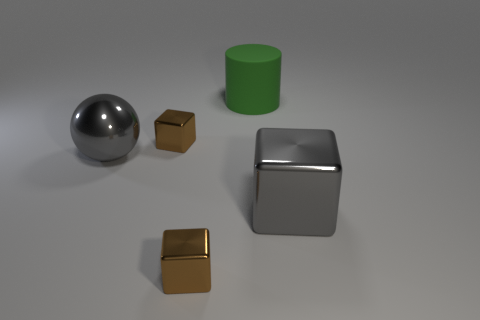Is there any other thing that is made of the same material as the big green cylinder?
Offer a terse response. No. Does the large green matte object have the same shape as the large gray object to the left of the green rubber object?
Give a very brief answer. No. What is the shape of the object that is the same color as the large sphere?
Provide a succinct answer. Cube. Are there fewer gray objects behind the gray metal block than large metal balls?
Offer a terse response. No. The gray cube that is the same material as the big ball is what size?
Provide a succinct answer. Large. Are there fewer tiny metal objects than big green matte cylinders?
Give a very brief answer. No. What number of tiny things are matte things or green rubber spheres?
Your answer should be compact. 0. What number of big objects are both behind the large gray shiny sphere and in front of the green thing?
Ensure brevity in your answer.  0. Is the number of big gray metallic things greater than the number of small brown metallic cylinders?
Provide a succinct answer. Yes. What number of other things are there of the same shape as the big green object?
Make the answer very short. 0. 